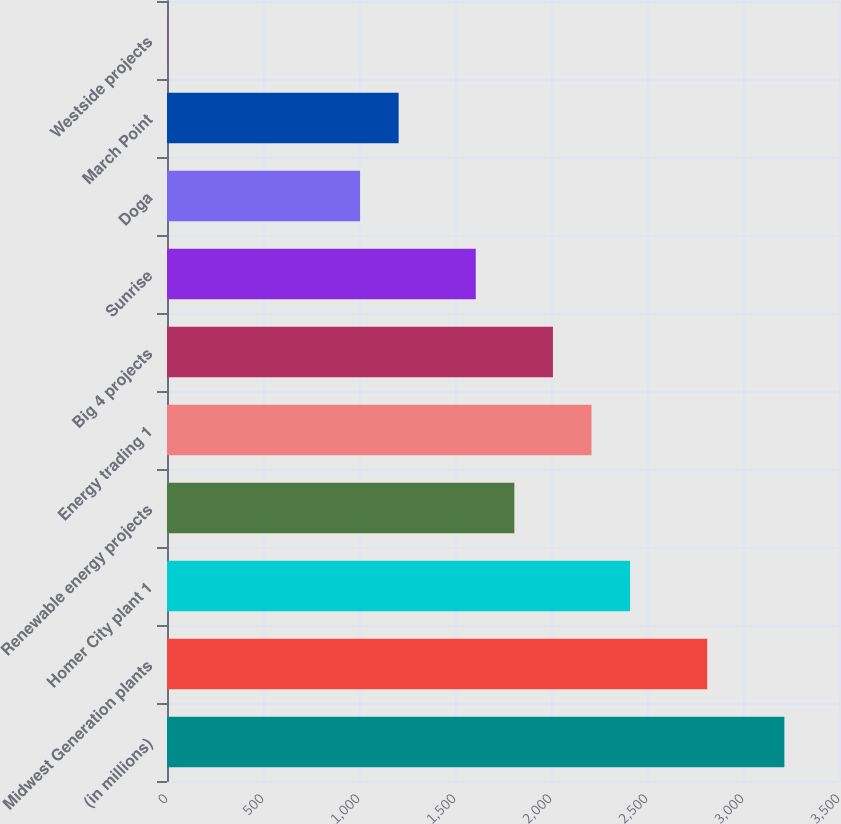Convert chart to OTSL. <chart><loc_0><loc_0><loc_500><loc_500><bar_chart><fcel>(in millions)<fcel>Midwest Generation plants<fcel>Homer City plant 1<fcel>Renewable energy projects<fcel>Energy trading 1<fcel>Big 4 projects<fcel>Sunrise<fcel>Doga<fcel>March Point<fcel>Westside projects<nl><fcel>3215.4<fcel>2813.6<fcel>2411.8<fcel>1809.1<fcel>2210.9<fcel>2010<fcel>1608.2<fcel>1005.5<fcel>1206.4<fcel>1<nl></chart> 